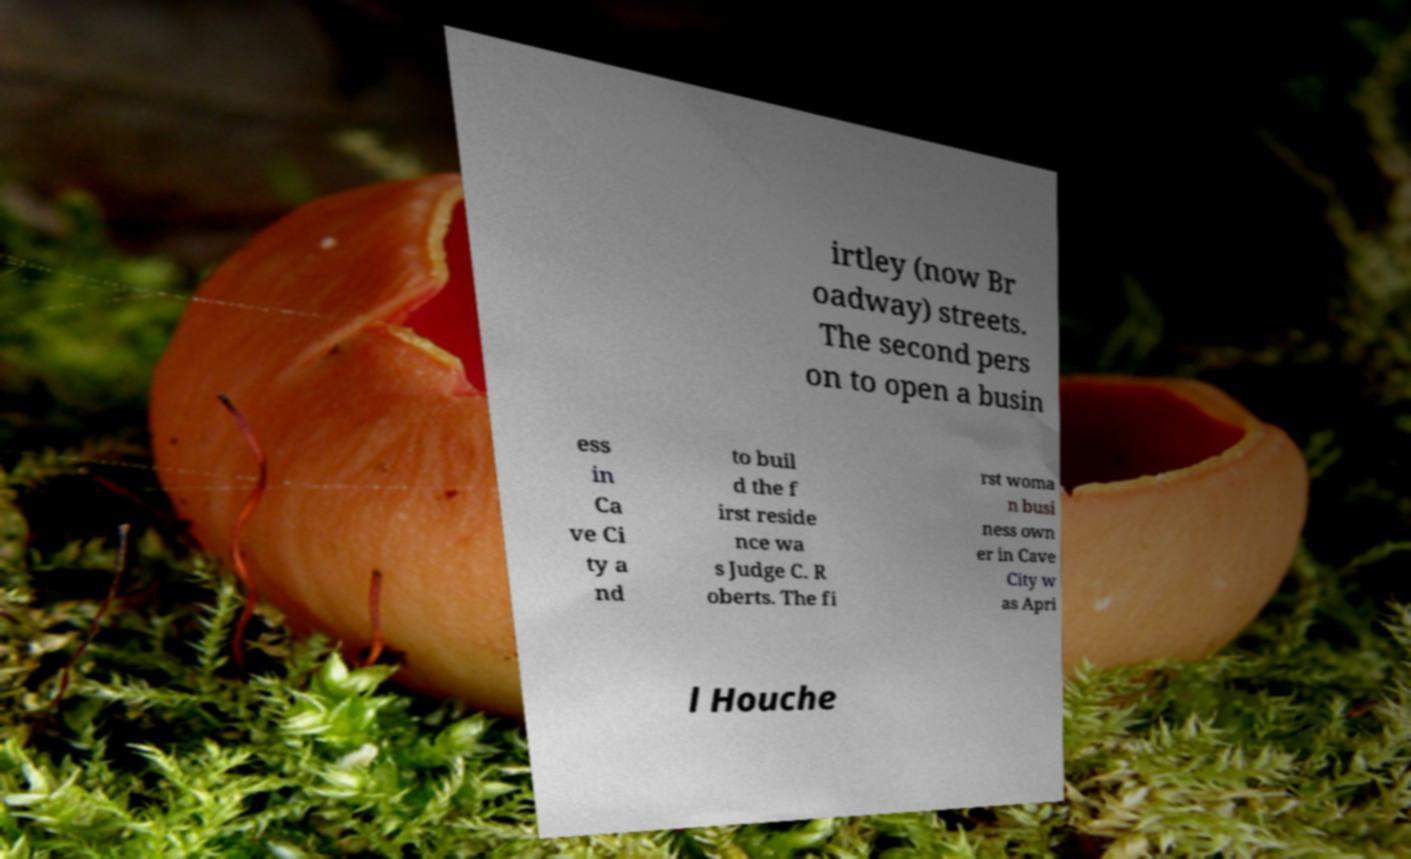Could you extract and type out the text from this image? irtley (now Br oadway) streets. The second pers on to open a busin ess in Ca ve Ci ty a nd to buil d the f irst reside nce wa s Judge C. R oberts. The fi rst woma n busi ness own er in Cave City w as Apri l Houche 